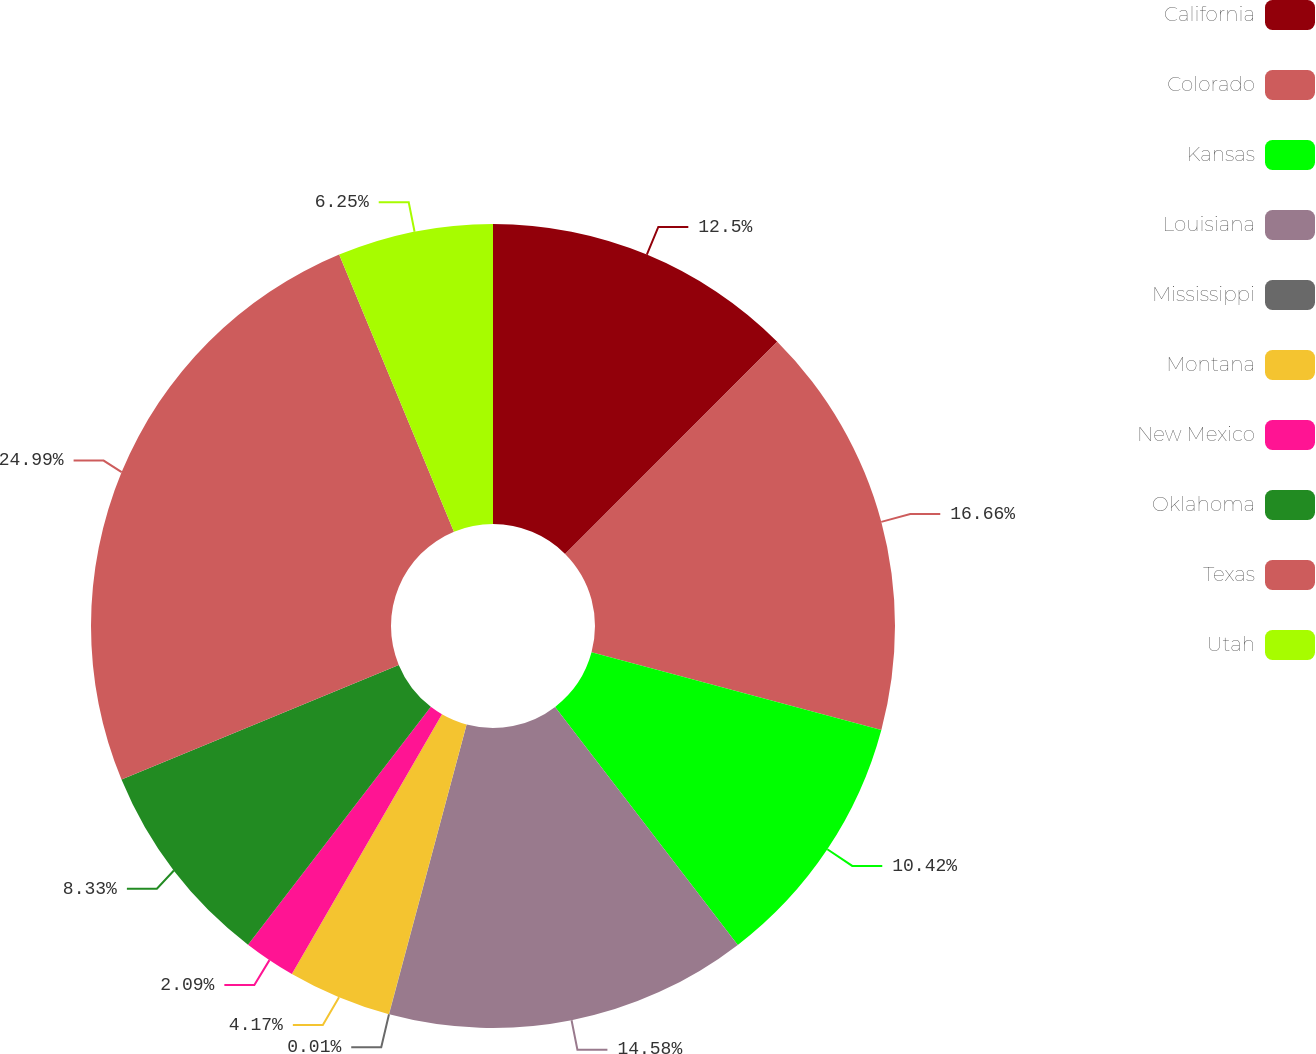Convert chart to OTSL. <chart><loc_0><loc_0><loc_500><loc_500><pie_chart><fcel>California<fcel>Colorado<fcel>Kansas<fcel>Louisiana<fcel>Mississippi<fcel>Montana<fcel>New Mexico<fcel>Oklahoma<fcel>Texas<fcel>Utah<nl><fcel>12.5%<fcel>16.66%<fcel>10.42%<fcel>14.58%<fcel>0.01%<fcel>4.17%<fcel>2.09%<fcel>8.33%<fcel>24.99%<fcel>6.25%<nl></chart> 